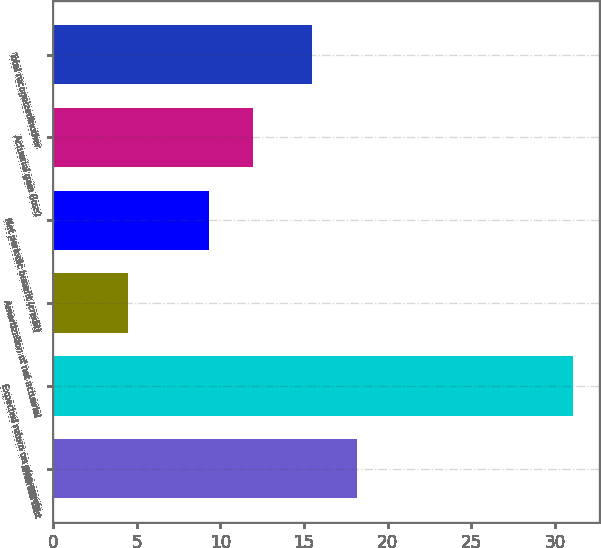Convert chart. <chart><loc_0><loc_0><loc_500><loc_500><bar_chart><fcel>Interest cost<fcel>Expected return on plan assets<fcel>Amortization of net actuarial<fcel>Net periodic benefit (credit)<fcel>Actuarial gain (loss)<fcel>Total recognizedinother<nl><fcel>18.16<fcel>31.1<fcel>4.5<fcel>9.3<fcel>11.96<fcel>15.5<nl></chart> 